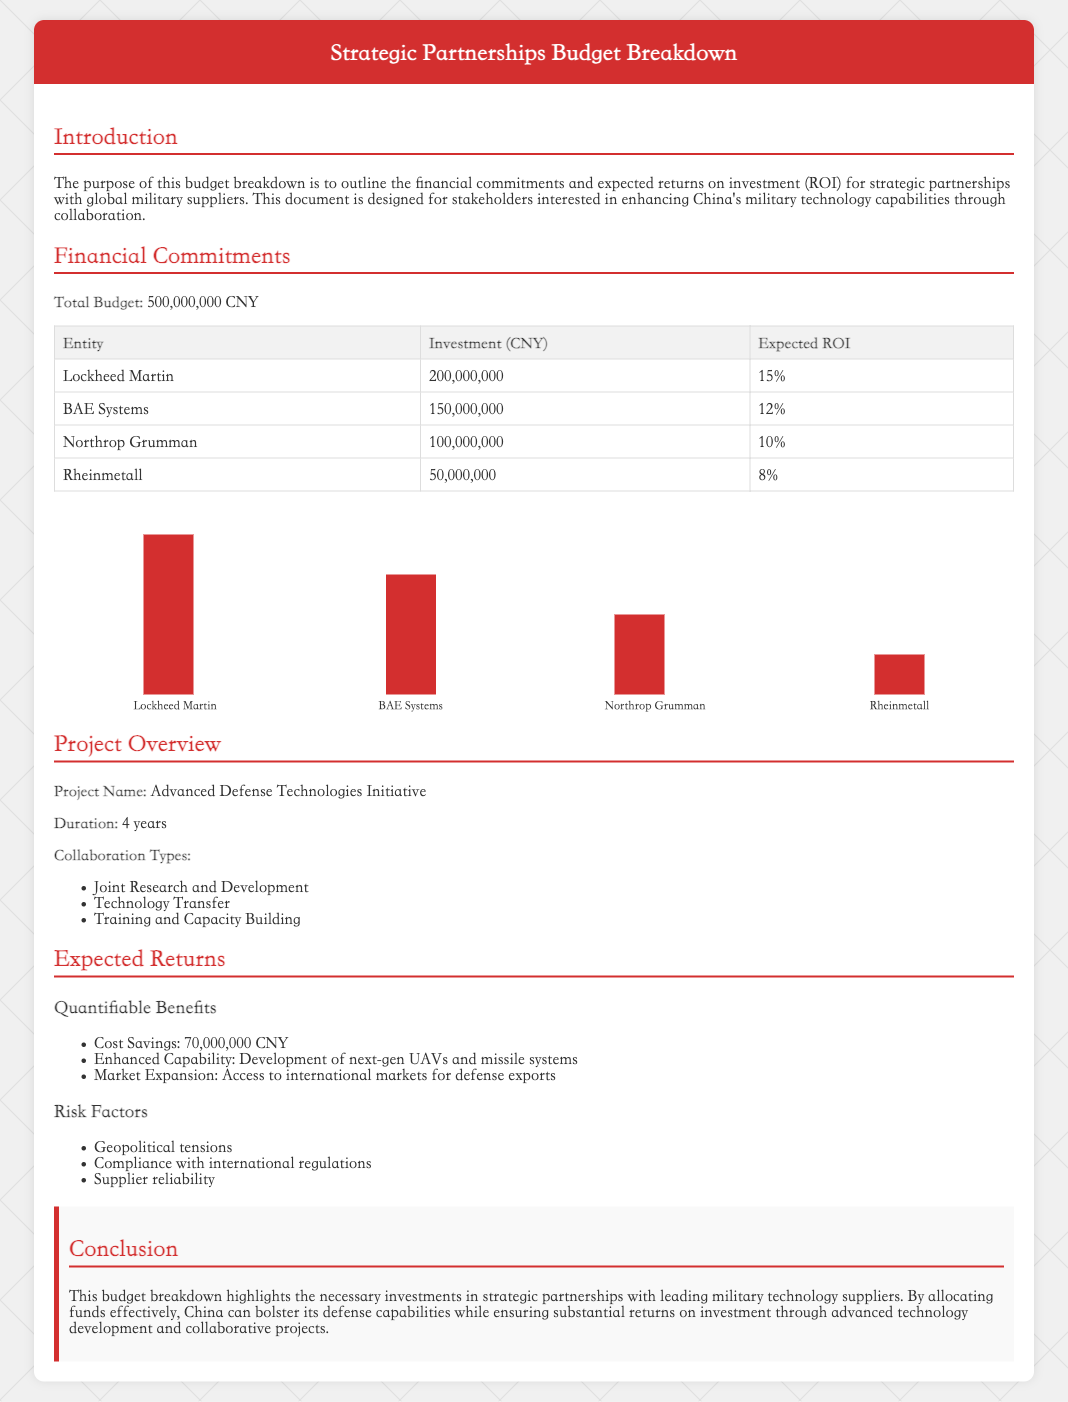What is the total budget? The total budget is explicitly mentioned in the document, which is 500,000,000 CNY.
Answer: 500,000,000 CNY Who is the largest entity receiving investment? The largest entity listed under financial commitments is Lockheed Martin, which has the highest investment amount.
Answer: Lockheed Martin What is the expected ROI for BAE Systems? The expected ROI for BAE Systems is stated as 12%.
Answer: 12% What type of project is outlined in the document? The document outlines the "Advanced Defense Technologies Initiative" as the name of the project.
Answer: Advanced Defense Technologies Initiative How long is the project duration? The duration of the project is specified as 4 years in the project overview.
Answer: 4 years What is the expected cost savings? The document lists the expected cost savings as 70,000,000 CNY.
Answer: 70,000,000 CNY What are two types of collaboration mentioned? The document lists "Joint Research and Development" and "Technology Transfer" as types of collaboration.
Answer: Joint Research and Development, Technology Transfer What is a risk factor mentioned in the document? The document identifies "Geopolitical tensions" as one of the risk factors for the project.
Answer: Geopolitical tensions What is one quantifiable benefit expected from the partnership? The document specifies "Enhanced Capability" as one of the quantifiable benefits from the partnership.
Answer: Enhanced Capability 